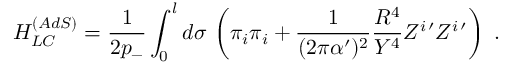Convert formula to latex. <formula><loc_0><loc_0><loc_500><loc_500>H _ { L C } ^ { ( A d S ) } = \frac { 1 } { 2 p _ { - } } \int _ { 0 } ^ { l } d \sigma \, \left ( \pi _ { i } \pi _ { i } + \frac { 1 } { ( 2 \pi \alpha ^ { \prime } ) ^ { 2 } } \frac { R ^ { 4 } } { Y ^ { 4 } } Z ^ { i \, \prime } Z ^ { i \, \prime } \right ) \ .</formula> 